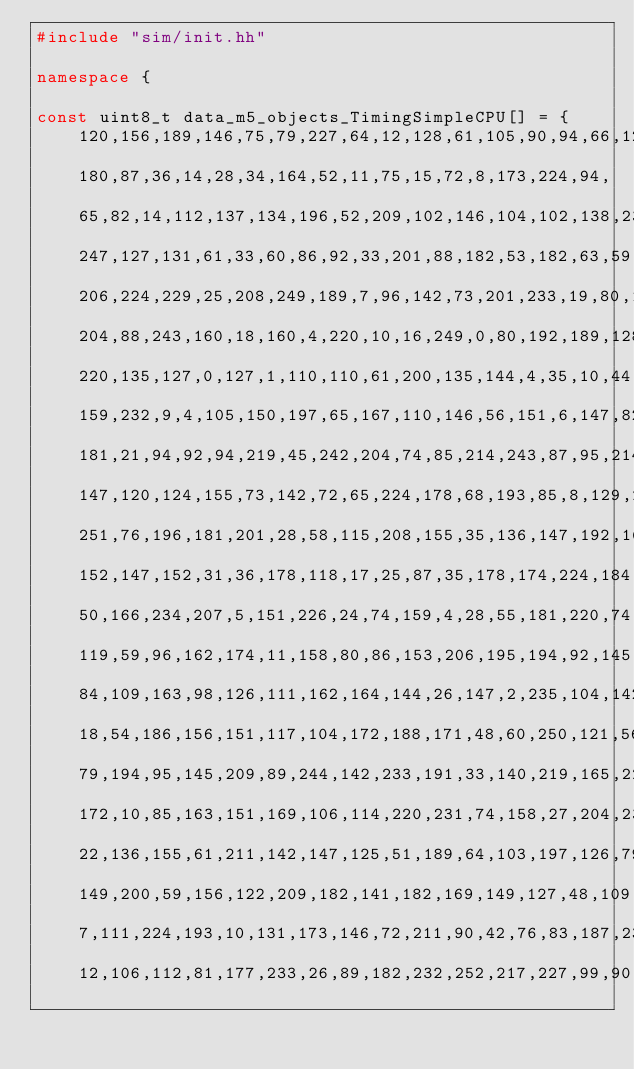Convert code to text. <code><loc_0><loc_0><loc_500><loc_500><_C++_>#include "sim/init.hh"

namespace {

const uint8_t data_m5_objects_TimingSimpleCPU[] = {
    120,156,189,146,75,79,227,64,12,128,61,105,90,94,66,128,
    180,87,36,14,28,34,164,52,11,75,15,72,8,173,224,94,
    65,82,14,112,137,134,196,52,209,102,146,104,102,138,232,121,
    247,127,131,61,33,60,86,92,33,201,88,182,53,182,63,59,
    206,224,229,25,208,249,189,7,96,142,73,201,233,19,80,1,
    204,88,243,160,18,160,4,220,10,16,249,0,80,192,189,128,
    220,135,127,0,127,1,110,110,61,200,135,144,4,35,10,44,
    159,232,9,4,105,150,197,65,167,110,146,56,151,6,147,82,
    181,21,94,92,94,219,45,242,204,74,85,214,243,87,95,214,
    147,120,124,155,73,142,72,65,224,178,68,193,85,8,129,202,
    251,76,196,181,201,28,58,115,208,155,35,136,147,192,167,176,
    152,147,152,31,36,178,118,17,25,87,35,178,174,224,184,40,
    50,166,234,207,5,151,226,24,74,159,4,28,55,181,220,74,
    119,59,96,162,174,11,158,80,86,153,206,195,194,92,145,136,
    84,109,163,98,126,111,162,164,144,26,147,2,235,104,142,106,
    18,54,186,156,151,117,104,172,188,171,48,60,250,121,56,9,
    79,194,95,145,209,89,244,142,233,191,33,140,219,165,221,160,
    172,10,85,163,151,169,106,114,220,231,74,158,27,204,231,220,
    22,136,155,61,211,142,147,125,51,189,64,103,197,126,79,251,
    149,200,59,156,122,209,182,141,182,169,149,127,48,109,30,80,
    7,111,224,193,10,131,173,146,72,211,90,42,76,83,187,238,
    12,106,112,81,177,233,26,89,182,232,252,217,227,99,90,160,</code> 